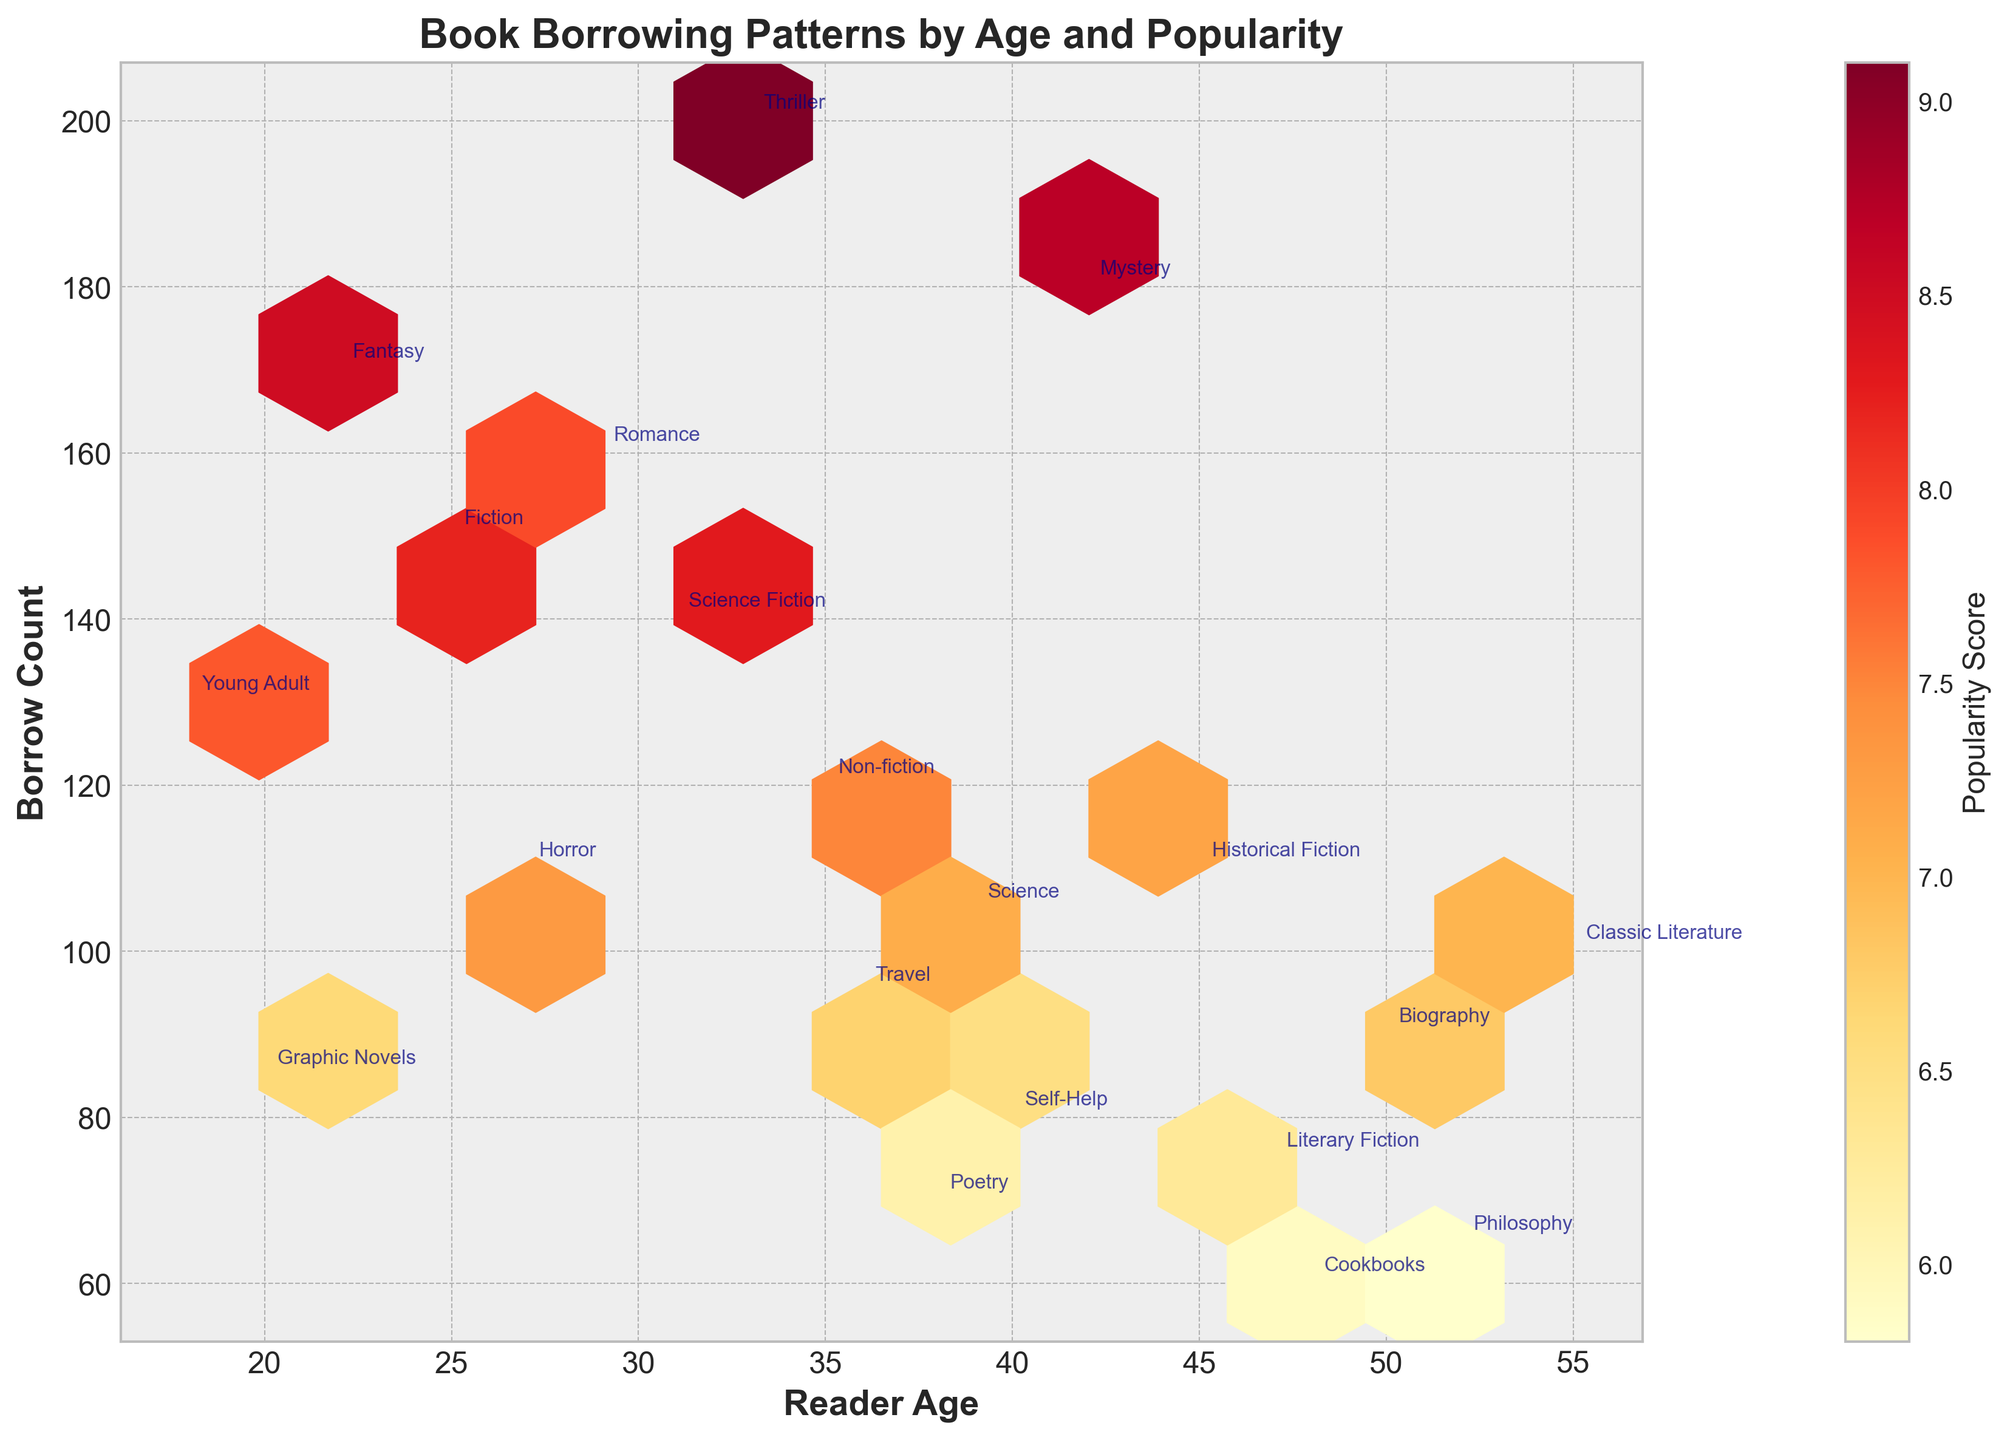what is the title of the figure? The title of the figure is printed at the top and is usually a brief description of what the chart represents. In this case, the title "Book Borrowing Patterns by Age and Popularity" describes the subject being visualized.
Answer: Book Borrowing Patterns by Age and Popularity How many age groups are represented in the data? The age groups are shown along the x-axis, with each unique age listed from the dataset. By counting the age labels along the x-axis, we can determine the number of age groups present.
Answer: 19 Which genre has the highest borrow count? By looking at the y-axis, which represents the borrow count, and referring to the labels annotating the points, you can identify the genre corresponding to the highest point on the y-axis.
Answer: Thriller How does the Popularity Score vary for the genres with similar ages (e.g., Science Fiction and Romance)? To analyze this, we compare the color intensity and the annotations for genres around similar ages. Science Fiction and Romance are around age 29 and 31. The color of the hexagons, represented by yellows and reds, can help to determine their Popularity Scores.
Answer: Science Fiction: 8.3, Romance: 7.9 Which age group tends to borrow the most books on average? To determine this, look for the densest clustered hexagons with high y-values on the y-axis, as the borrow count represents the number of books borrowed. This is often apparent in the regions where data points are more concentrated.
Answer: Ages around 33 to 38 Is there a discernible trend between reader age and borrow count for any particular genre? Look for a pattern of increasing or decreasing borrow counts along the y-axis for specific genres as age changes along the x-axis. Annotated labels will help identify the corresponding genres.
Answer: Younger readers tend to borrow more Fantasy and Young Adult books, while older readers show a decrease in borrow counts across various genres What is the hex color representing the highest Popularity Score and which genre does it belong to? The color bar provides a gradient of colors corresponding to Popularity Scores. Identify the genre near the hexagon with the darkest red color, indicating the highest Popularity Score.
Answer: Dark red, Thriller Compare the Borrow Counts of Mystery and Biography genres. Which has higher Borrow Count and by how much? Locate the annotation labels for Mystery and Biography on the plot. The y-axis value of Mystery is 180 and Biography is 90. Subtract the lower borrow count from the higher to determine the difference.
Answer: Mystery has 90 more Borrow Counts than Biography What kind of correlation, if any, can be observed between Borrow Count and Popularity Score across genres? Observe the overall spread of the hexagons, the coloring, and the density of hexagons to determine if higher borrow counts generally lead to higher Popularity Scores (indicated by more intense colors).
Answer: Positive correlation: Higher Borrow Counts generally result in higher Popularity Scores Among the genres annotated near ages 40-50, which genre stands out in terms of Popularity Score? Using the color bar and the annotated labels near ages 40-50 on the x-axis, identify the genre with the hexagon that has the most intense color shade.
Answer: Thriller 